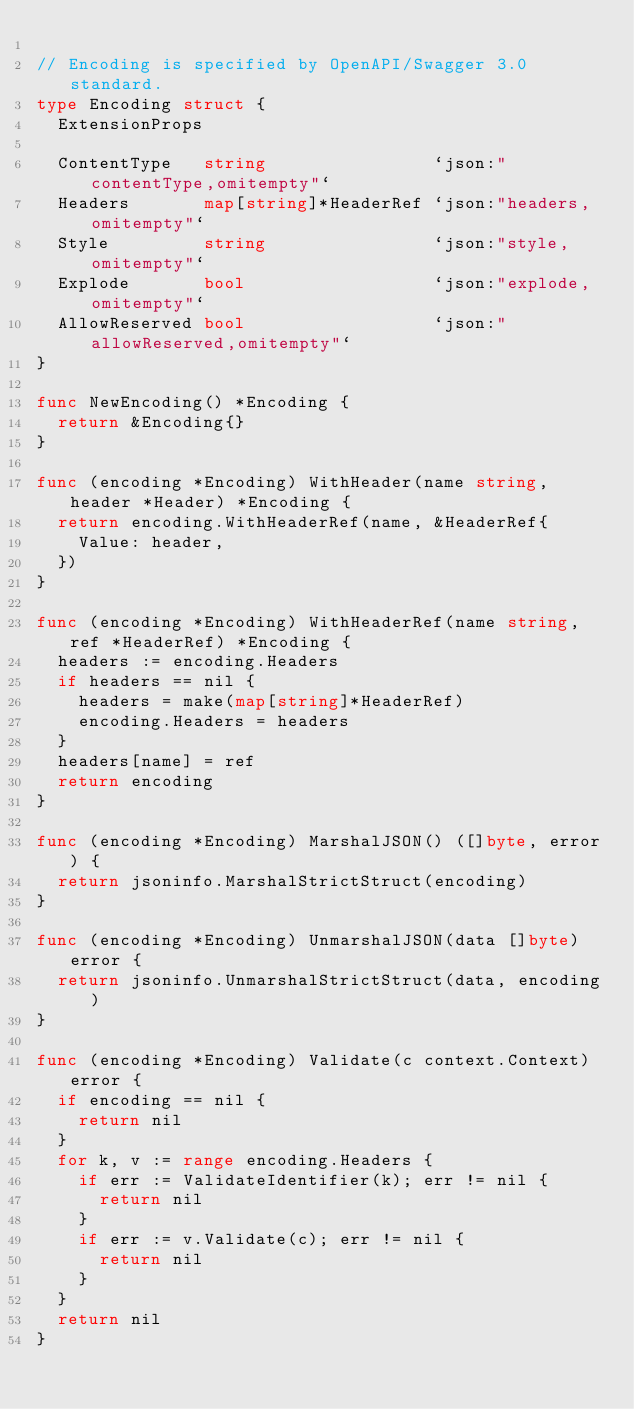Convert code to text. <code><loc_0><loc_0><loc_500><loc_500><_Go_>
// Encoding is specified by OpenAPI/Swagger 3.0 standard.
type Encoding struct {
	ExtensionProps

	ContentType   string                `json:"contentType,omitempty"`
	Headers       map[string]*HeaderRef `json:"headers,omitempty"`
	Style         string                `json:"style,omitempty"`
	Explode       bool                  `json:"explode,omitempty"`
	AllowReserved bool                  `json:"allowReserved,omitempty"`
}

func NewEncoding() *Encoding {
	return &Encoding{}
}

func (encoding *Encoding) WithHeader(name string, header *Header) *Encoding {
	return encoding.WithHeaderRef(name, &HeaderRef{
		Value: header,
	})
}

func (encoding *Encoding) WithHeaderRef(name string, ref *HeaderRef) *Encoding {
	headers := encoding.Headers
	if headers == nil {
		headers = make(map[string]*HeaderRef)
		encoding.Headers = headers
	}
	headers[name] = ref
	return encoding
}

func (encoding *Encoding) MarshalJSON() ([]byte, error) {
	return jsoninfo.MarshalStrictStruct(encoding)
}

func (encoding *Encoding) UnmarshalJSON(data []byte) error {
	return jsoninfo.UnmarshalStrictStruct(data, encoding)
}

func (encoding *Encoding) Validate(c context.Context) error {
	if encoding == nil {
		return nil
	}
	for k, v := range encoding.Headers {
		if err := ValidateIdentifier(k); err != nil {
			return nil
		}
		if err := v.Validate(c); err != nil {
			return nil
		}
	}
	return nil
}
</code> 